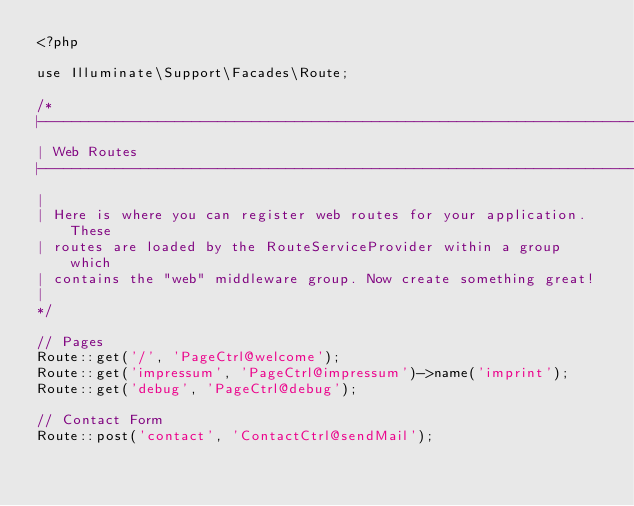Convert code to text. <code><loc_0><loc_0><loc_500><loc_500><_PHP_><?php

use Illuminate\Support\Facades\Route;

/*
|--------------------------------------------------------------------------
| Web Routes
|--------------------------------------------------------------------------
|
| Here is where you can register web routes for your application. These
| routes are loaded by the RouteServiceProvider within a group which
| contains the "web" middleware group. Now create something great!
|
*/

// Pages
Route::get('/', 'PageCtrl@welcome');
Route::get('impressum', 'PageCtrl@impressum')->name('imprint');
Route::get('debug', 'PageCtrl@debug');

// Contact Form
Route::post('contact', 'ContactCtrl@sendMail');
</code> 